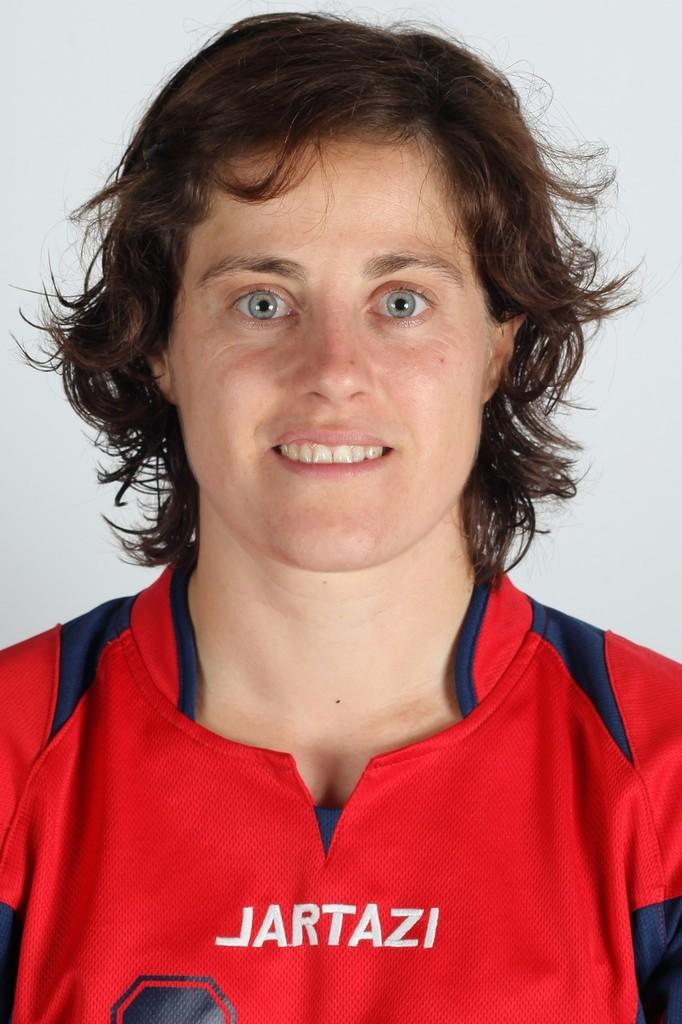<image>
Relay a brief, clear account of the picture shown. Woman wearing a red jersey which says JARTAZI. 